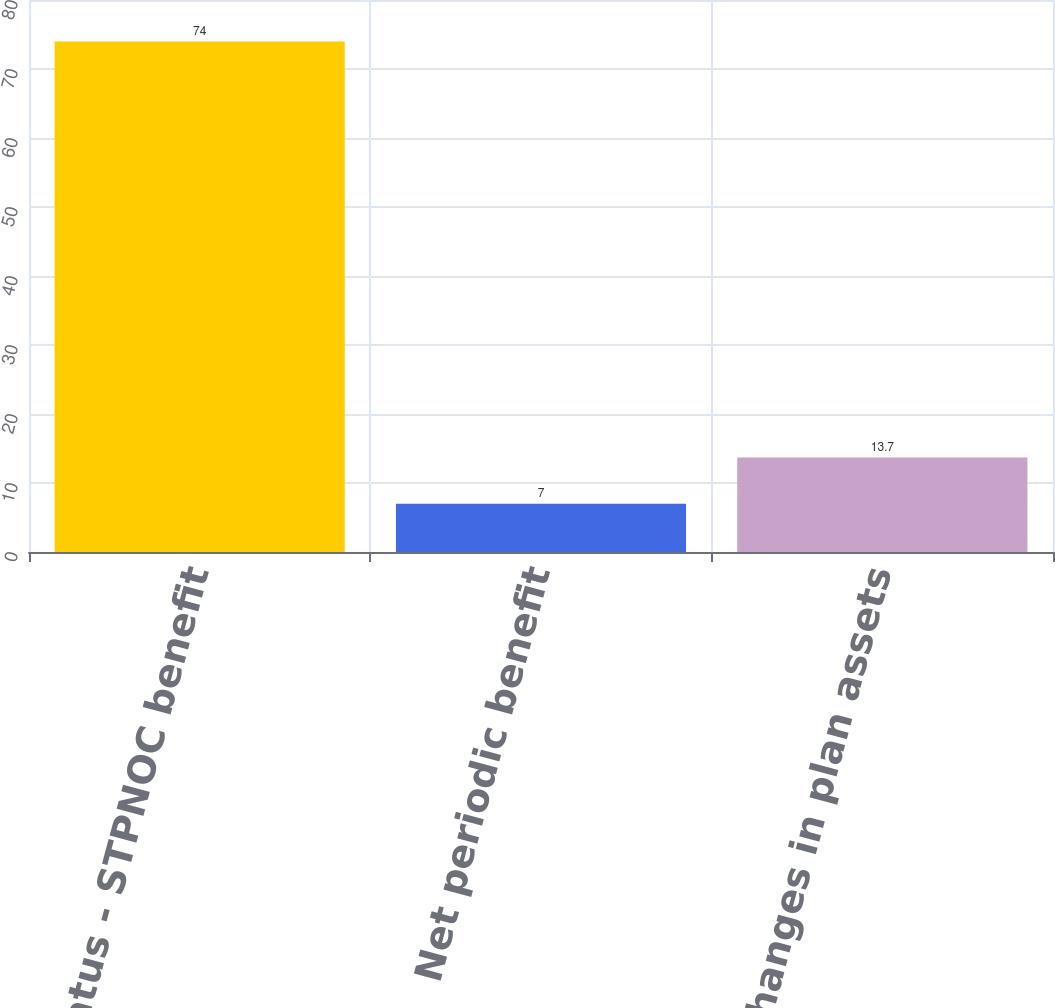Convert chart to OTSL. <chart><loc_0><loc_0><loc_500><loc_500><bar_chart><fcel>Funded status - STPNOC benefit<fcel>Net periodic benefit<fcel>Other changes in plan assets<nl><fcel>74<fcel>7<fcel>13.7<nl></chart> 